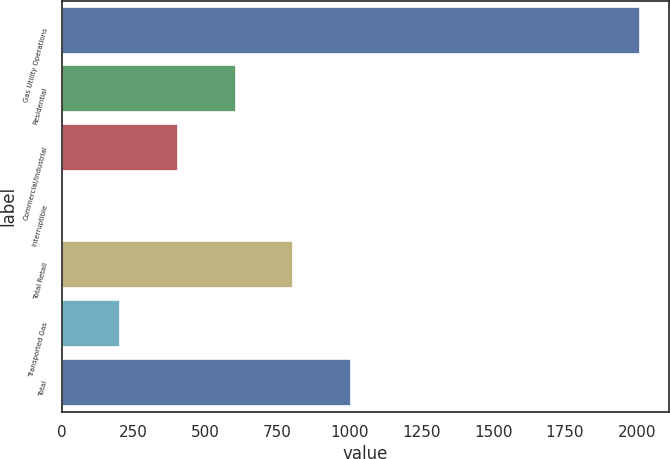Convert chart. <chart><loc_0><loc_0><loc_500><loc_500><bar_chart><fcel>Gas Utility Operations<fcel>Residential<fcel>Commercial/Industrial<fcel>Interruptible<fcel>Total Retail<fcel>Transported Gas<fcel>Total<nl><fcel>2012<fcel>604.79<fcel>403.76<fcel>1.7<fcel>805.82<fcel>202.73<fcel>1006.85<nl></chart> 